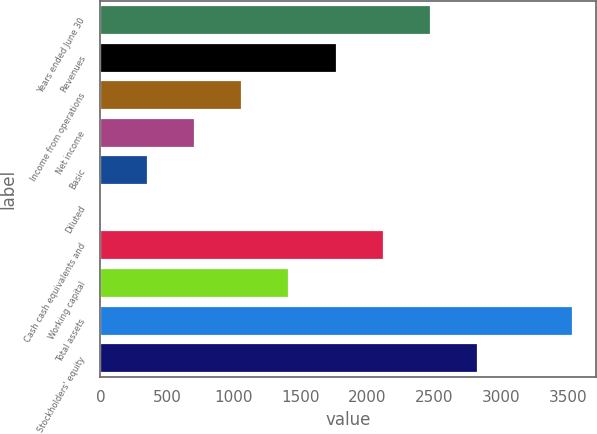Convert chart. <chart><loc_0><loc_0><loc_500><loc_500><bar_chart><fcel>Years ended June 30<fcel>Revenues<fcel>Income from operations<fcel>Net income<fcel>Basic<fcel>Diluted<fcel>Cash cash equivalents and<fcel>Working capital<fcel>Total assets<fcel>Stockholders' equity<nl><fcel>2477.67<fcel>1770.11<fcel>1062.55<fcel>708.77<fcel>354.99<fcel>1.21<fcel>2123.89<fcel>1416.33<fcel>3539<fcel>2831.45<nl></chart> 